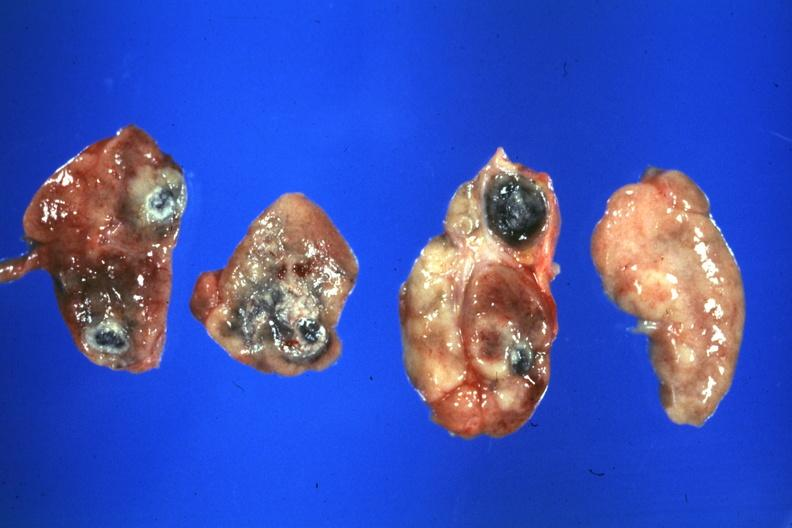what is present?
Answer the question using a single word or phrase. Lymph node 